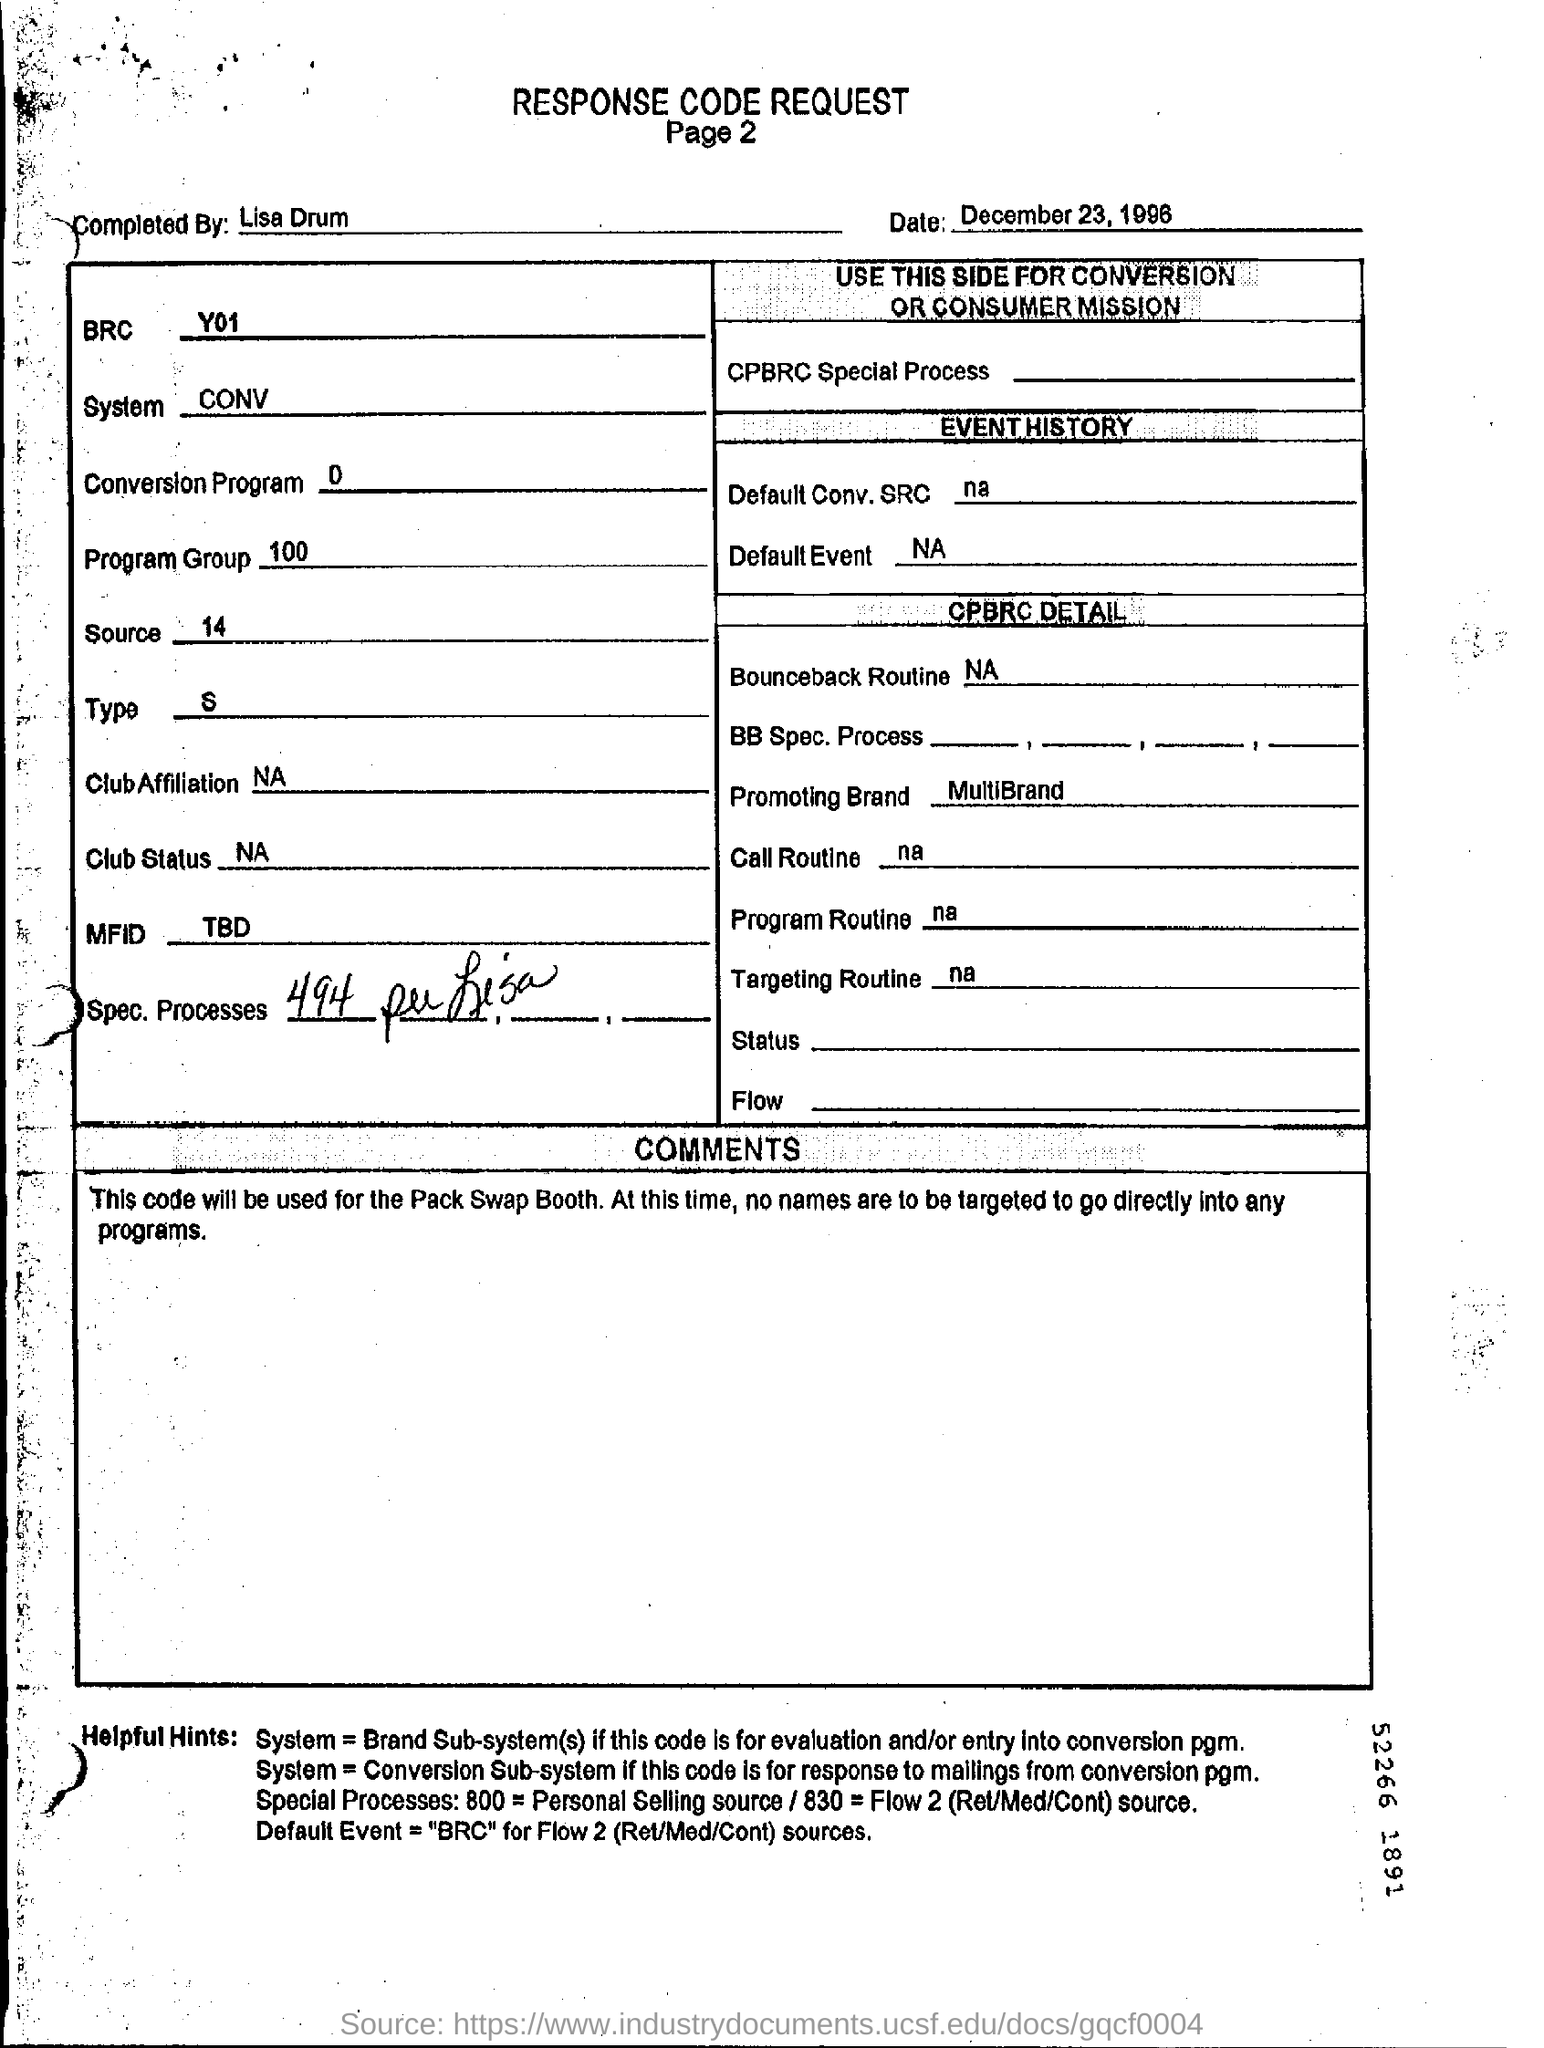What is the date mentioned in the request form?
Provide a succinct answer. December 23, 1996. Who completed this request form?
Your answer should be compact. Lisa Drum. Which program Group is mentioned?
Give a very brief answer. 100. What is the "source" as per the form?
Ensure brevity in your answer.  14. What is the "conversion program" as per the form?
Offer a very short reply. 0. 